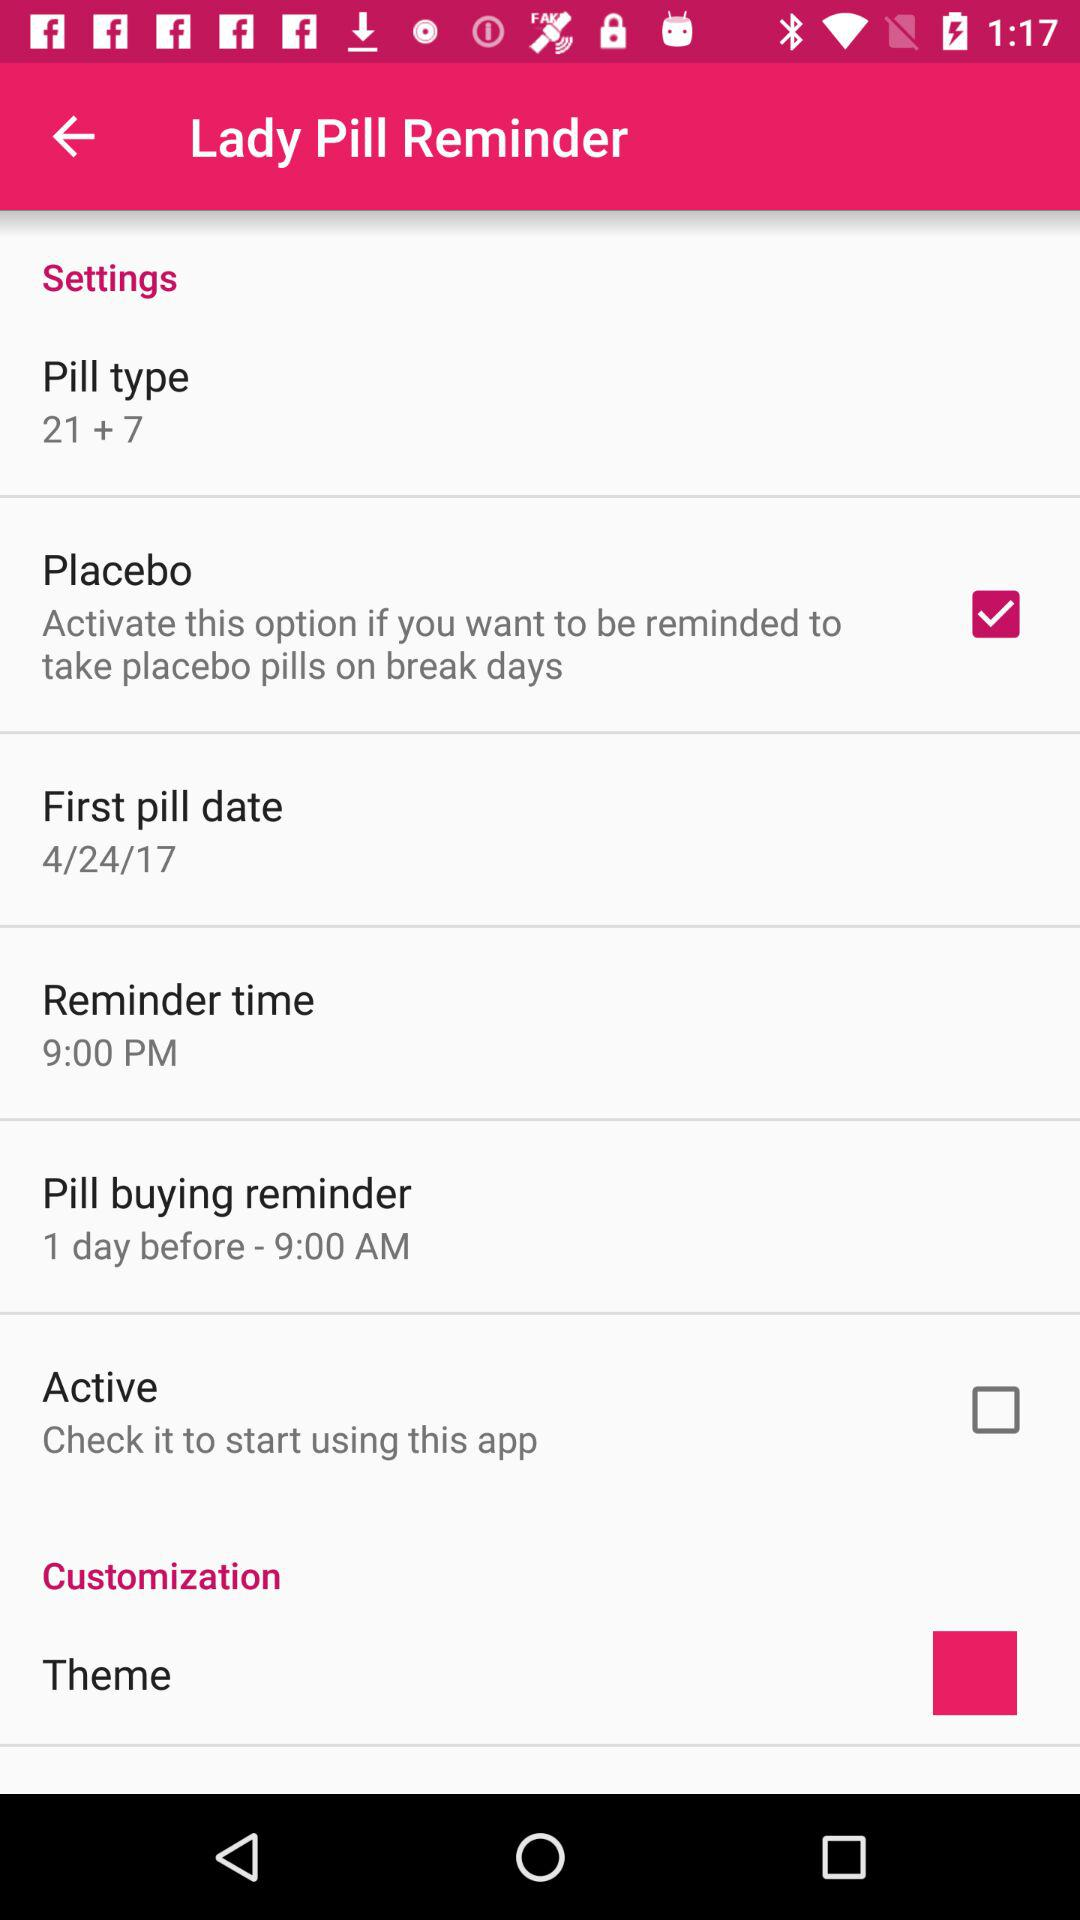What is the current status of "Active"? The current status is "off". 